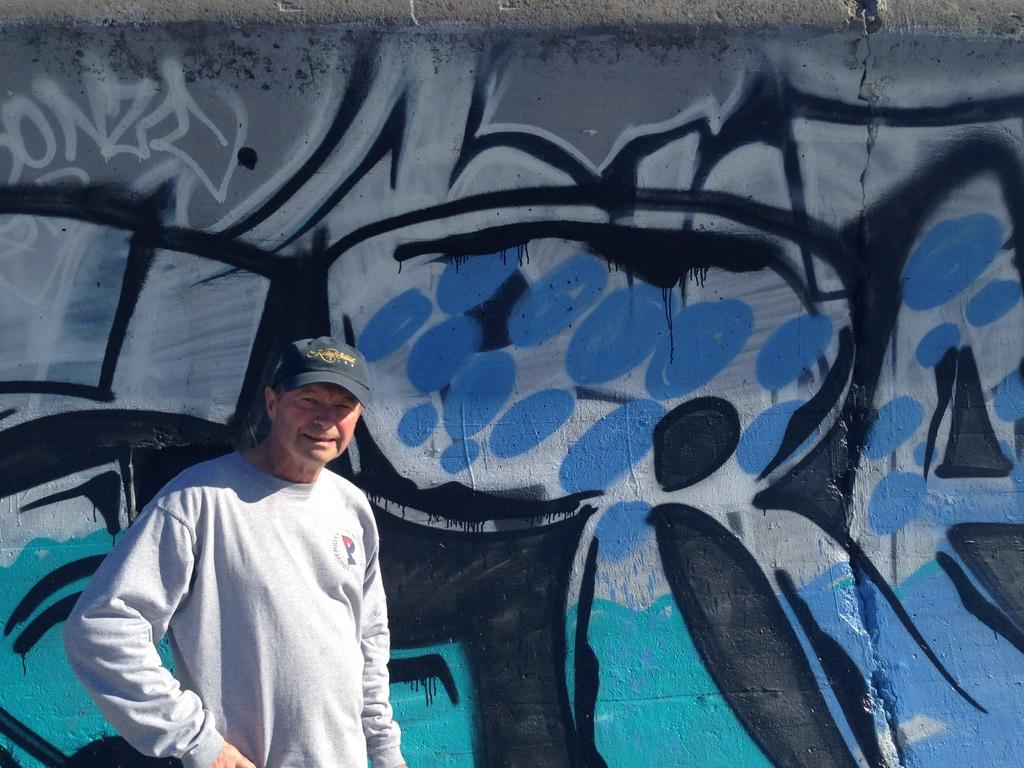Who is the main subject in the picture? There is an old man in the picture. What is the old man wearing? The old man is wearing a grey t-shirt and a cap. What is the old man doing in the picture? The old man is standing and giving a pose for the camera. What can be seen in the background of the picture? There is a blue and black color spray painted wall in the background. What type of clocks can be seen hanging on the wall in the image? There are no clocks visible in the image; the background features a blue and black color spray painted wall. Can you see a bat flying in the air in the image? There is no bat or air visible in the image; it is a picture of an old man standing in front of a wall. 